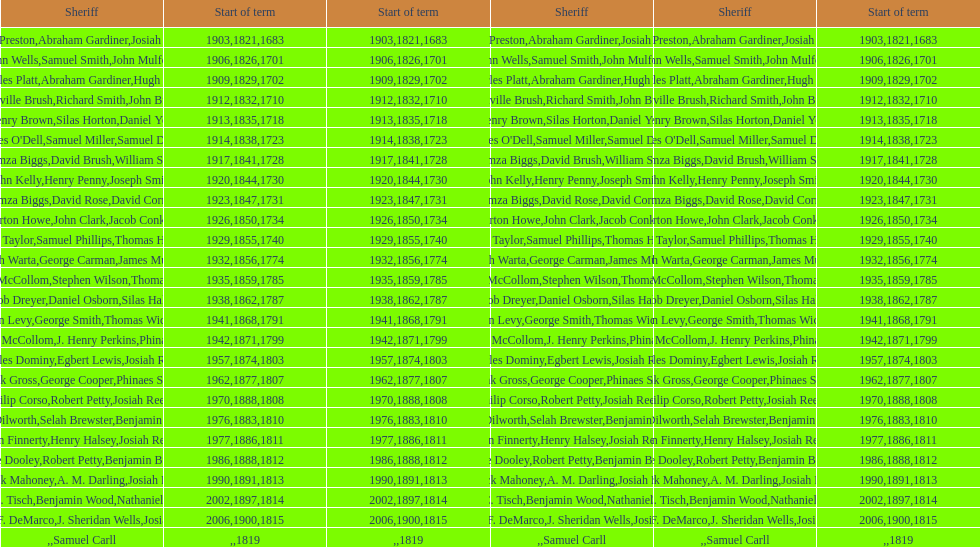What is the total number of sheriffs that were in office in suffolk county between 1903 and 1957? 17. 